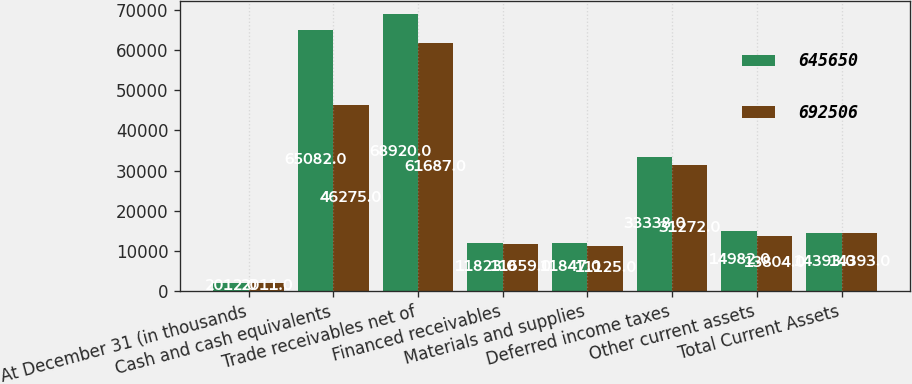<chart> <loc_0><loc_0><loc_500><loc_500><stacked_bar_chart><ecel><fcel>At December 31 (in thousands<fcel>Cash and cash equivalents<fcel>Trade receivables net of<fcel>Financed receivables<fcel>Materials and supplies<fcel>Deferred income taxes<fcel>Other current assets<fcel>Total Current Assets<nl><fcel>645650<fcel>2012<fcel>65082<fcel>68920<fcel>11823<fcel>11847<fcel>33338<fcel>14982<fcel>14393<nl><fcel>692506<fcel>2011<fcel>46275<fcel>61687<fcel>11659<fcel>11125<fcel>31272<fcel>13804<fcel>14393<nl></chart> 